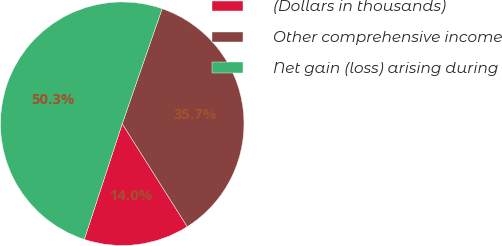Convert chart. <chart><loc_0><loc_0><loc_500><loc_500><pie_chart><fcel>(Dollars in thousands)<fcel>Other comprehensive income<fcel>Net gain (loss) arising during<nl><fcel>14.01%<fcel>35.72%<fcel>50.27%<nl></chart> 